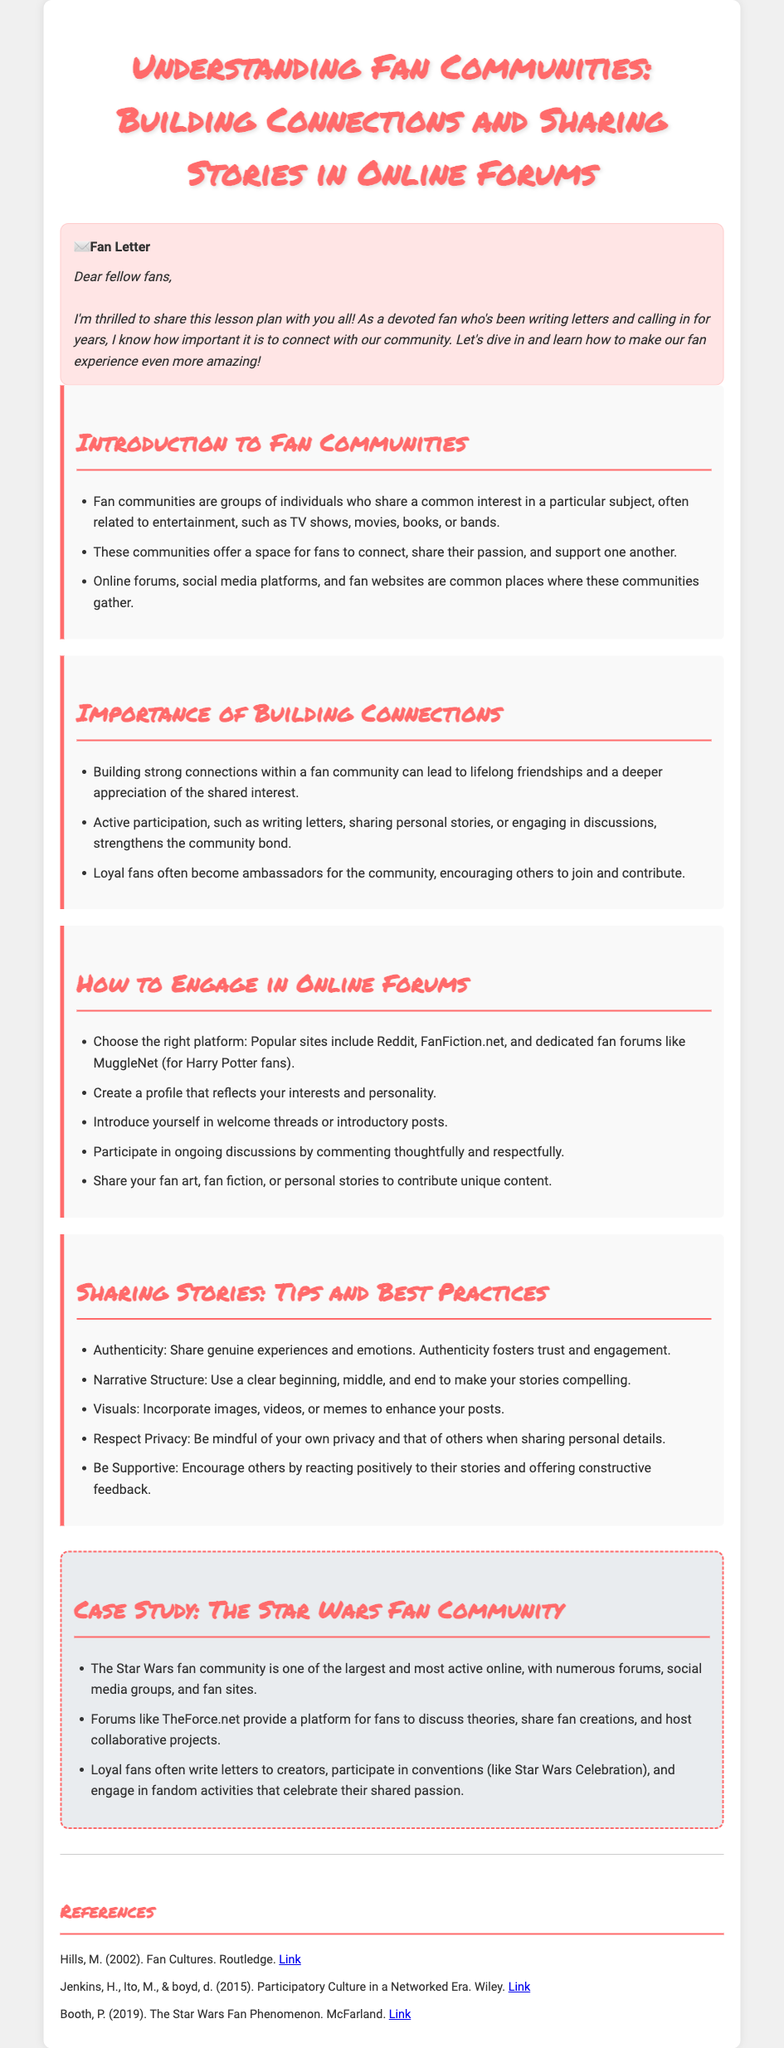What is the title of the lesson plan? The title of the lesson plan is provided at the beginning of the document, specifically formatted in the header.
Answer: Understanding Fan Communities: Building Connections and Sharing Stories in Online Forums What platform is mentioned for fan engagement? The lesson plan lists several platforms, among which one is particularly stated as a popular site for fans.
Answer: Reddit What is one purpose of fan communities? The document outlines several purposes, one of which is explicitly mentioned in the first section.
Answer: Connect How do loyal fans contribute to their communities? The lesson plan explains that loyal fans often take on specific roles within their communities, which is highlighted in the section discussing the importance of building connections.
Answer: Ambassadors Which narrative structure should be used in stories? The document provides guidelines for sharing personal stories, specifically mentioning the structure that should be employed.
Answer: Beginning, middle, and end What is a unique aspect of the Star Wars fan community? The case study describes particular characteristics of the Star Wars fan community that distinguish it among other fan groups.
Answer: Largest and most active How should visuals be used when sharing stories? The guidelines in the document suggest a specific way that visuals enhance storytelling within the community.
Answer: Enhance posts What type of connection do fan communities foster? The lesson plan emphasizes the nature of relationships that develop within fan communities, illustrating a beneficial outcome.
Answer: Lifelong friendships 